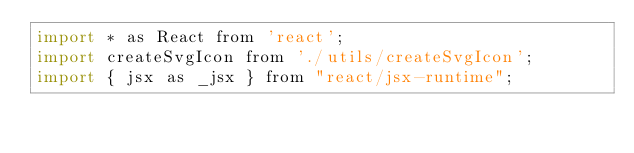Convert code to text. <code><loc_0><loc_0><loc_500><loc_500><_JavaScript_>import * as React from 'react';
import createSvgIcon from './utils/createSvgIcon';
import { jsx as _jsx } from "react/jsx-runtime";</code> 